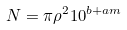<formula> <loc_0><loc_0><loc_500><loc_500>N = \pi \rho ^ { 2 } 1 0 ^ { b + a m }</formula> 